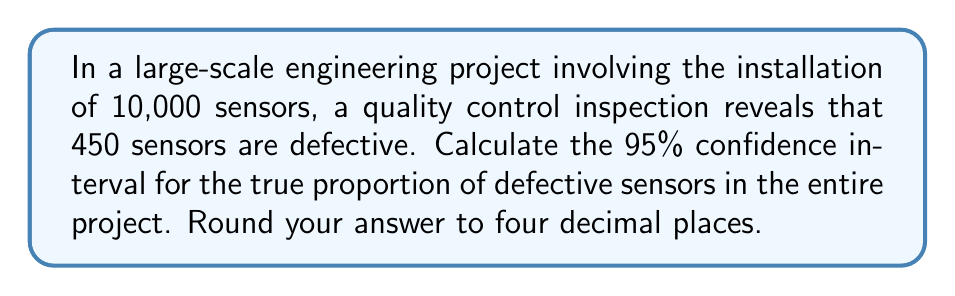Can you solve this math problem? Let's approach this step-by-step:

1) First, we need to identify our parameters:
   - Sample size: $n = 10,000$
   - Number of defective sensors: $X = 450$
   - Confidence level: 95% (corresponding to $z = 1.96$)

2) Calculate the sample proportion:
   $\hat{p} = \frac{X}{n} = \frac{450}{10,000} = 0.045$

3) The formula for the confidence interval of a population proportion is:
   $$\hat{p} \pm z\sqrt{\frac{\hat{p}(1-\hat{p})}{n}}$$

4) Calculate the standard error:
   $$SE = \sqrt{\frac{\hat{p}(1-\hat{p})}{n}} = \sqrt{\frac{0.045(1-0.045)}{10,000}} = 0.002072$$

5) Calculate the margin of error:
   $$ME = z \cdot SE = 1.96 \cdot 0.002072 = 0.004061$$

6) Calculate the confidence interval:
   Lower bound: $0.045 - 0.004061 = 0.040939$
   Upper bound: $0.045 + 0.004061 = 0.049061$

7) Rounding to four decimal places:
   (0.0409, 0.0491)

Therefore, we can be 95% confident that the true proportion of defective sensors in the entire project lies between 0.0409 and 0.0491, or 4.09% to 4.91%.
Answer: (0.0409, 0.0491) 